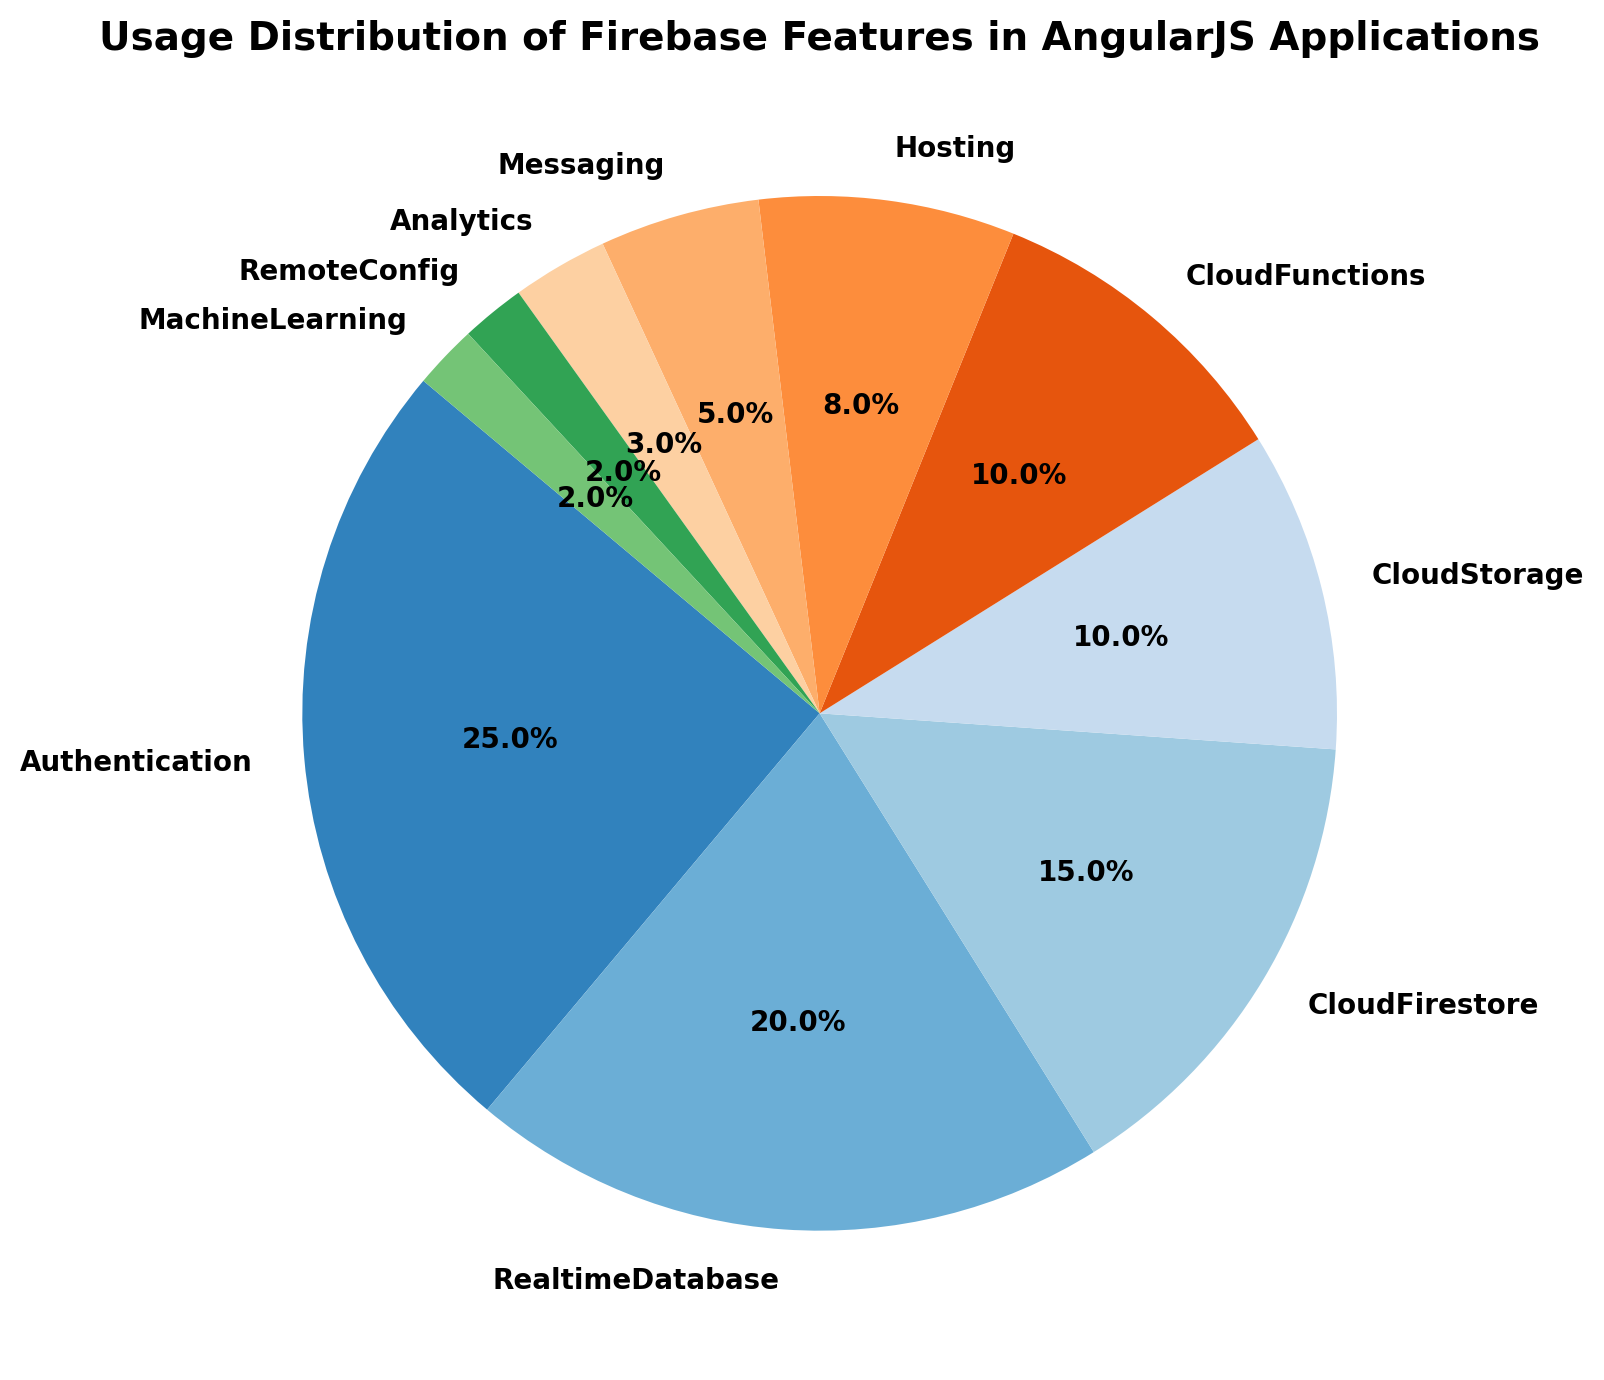What's the second most used Firebase feature in AngularJS applications? By looking at the pie chart, the slice with the second largest percentage after "Authentication" (25%) is "RealtimeDatabase" (20%).
Answer: RealtimeDatabase What’s the combined usage percentage of CloudFirestore, CloudStorage, and CloudFunctions? To find the combined usage, sum the individual percentages: CloudFirestore (15%) + CloudStorage (10%) + CloudFunctions (10%). So, 15 + 10 + 10 = 35%.
Answer: 35% Which features have usage percentages less than 5%? Identify the slices with percentages less than 5% in the pie chart: Messaging (5%), Analytics (3%), RemoteConfig (2%), and MachineLearning (2%). Since Messaging is exactly 5%, it doesn't qualify. The features below 5% are Analytics, RemoteConfig, and MachineLearning.
Answer: Analytics, RemoteConfig, MachineLearning Compare the usage percentages of Hosting and Messaging. Which one is higher and by how much? From the chart, Hosting has a usage percentage of 8%, and Messaging has 5%. The difference is 8% - 5% = 3%. So, Hosting is higher by 3%.
Answer: Hosting by 3% What’s the cumulative usage percentage of features used less than 10% each? Add the usage percentages of features with less than 10%: Hosting (8%) + Messaging (5%) + Analytics (3%) + RemoteConfig (2%) + MachineLearning (2%) = 8 + 5 + 3 + 2 + 2 = 20%.
Answer: 20% Which feature is represented by the largest slice, and what is its color? The largest slice on the pie chart represents the "Authentication" feature with 25%. The color might vary, but typically, the palette chosen will give it a prominent color that stands out.
Answer: Authentication, prominent color If features with usage above 10% represent the core functionalities, how many core functionalities are there? Identify features with usage percentages above 10%: Authentication (25%), RealtimeDatabase (20%), CloudFirestore (15%), CloudStorage (10%), CloudFunctions (10%). There are 5 such features.
Answer: 5 What percentage difference is there between the most and least used Firebase features? The most used feature is Authentication with 25%, and the least used are RemoteConfig and MachineLearning both with 2%. The difference is 25% - 2% = 23%.
Answer: 23% Which feature usage would need a 5% increase to be equal to CloudFirestore’s current usage? CloudFirestore has a usage of 15%. Currently, the feature closest and needing less than a 5% increase is CloudStorage or CloudFunctions both with 10%. Adding 5% to 10% makes it 15%, equal to CloudFirestore.
Answer: CloudStorage or CloudFunctions 